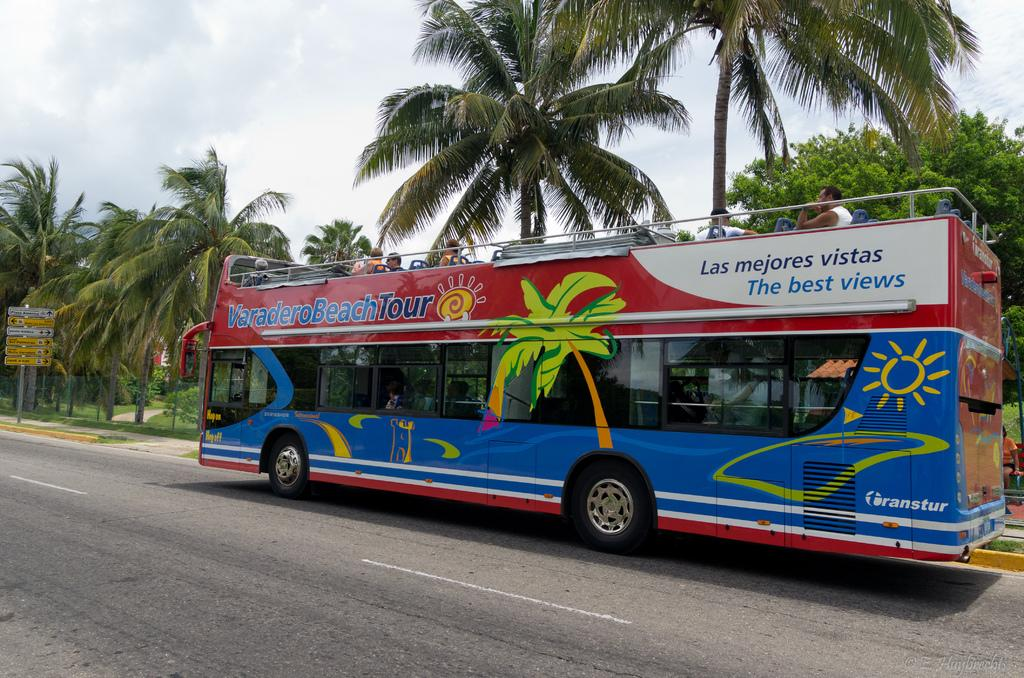<image>
Summarize the visual content of the image. A large bus that says Varadero Beach Tour. 